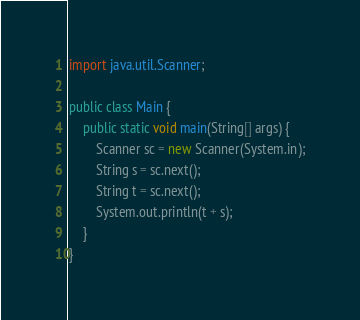Convert code to text. <code><loc_0><loc_0><loc_500><loc_500><_Java_>import java.util.Scanner;

public class Main {
    public static void main(String[] args) {
        Scanner sc = new Scanner(System.in);
        String s = sc.next();
        String t = sc.next();
        System.out.println(t + s);
    }
}
</code> 